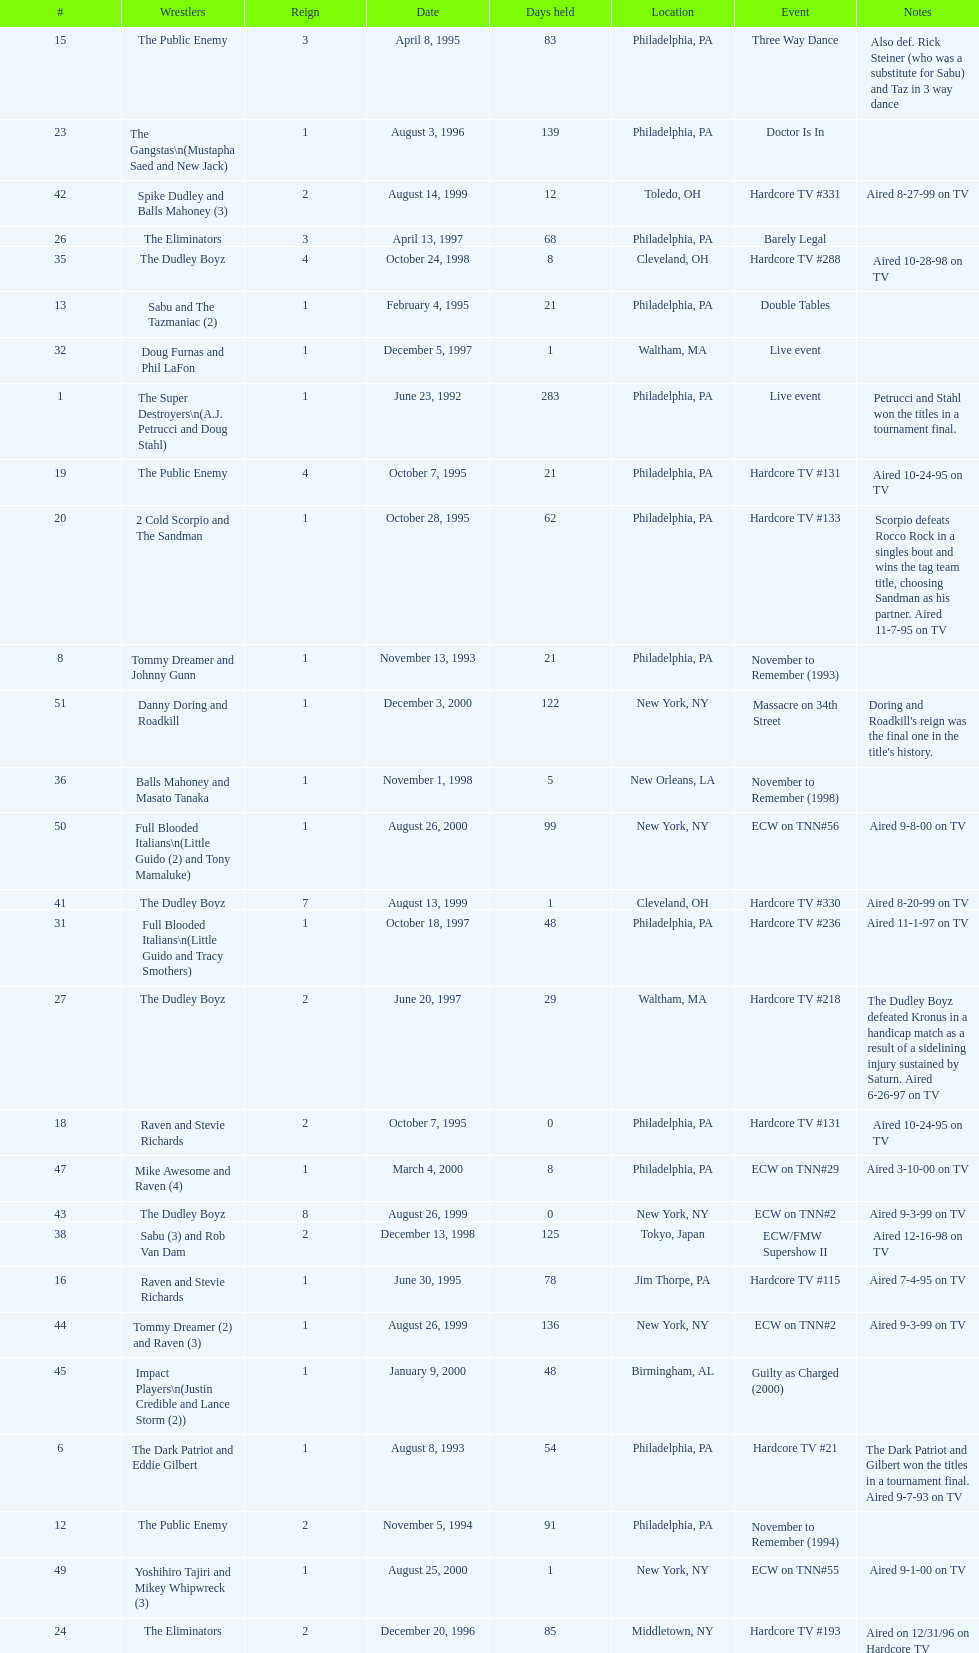Who held the title the most times, the super destroyers or the dudley boyz? The Dudley Boyz. 